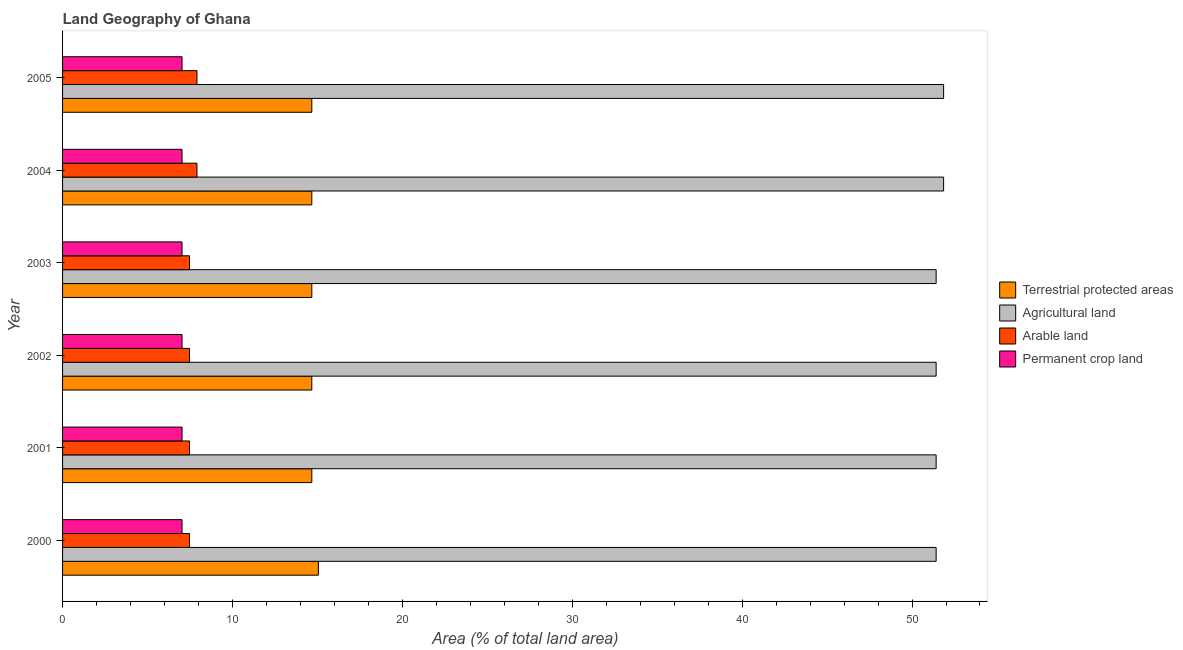How many groups of bars are there?
Offer a very short reply. 6. Are the number of bars per tick equal to the number of legend labels?
Give a very brief answer. Yes. How many bars are there on the 3rd tick from the top?
Provide a succinct answer. 4. How many bars are there on the 1st tick from the bottom?
Your answer should be compact. 4. In how many cases, is the number of bars for a given year not equal to the number of legend labels?
Ensure brevity in your answer.  0. What is the percentage of land under terrestrial protection in 2004?
Give a very brief answer. 14.67. Across all years, what is the maximum percentage of area under agricultural land?
Keep it short and to the point. 51.86. Across all years, what is the minimum percentage of area under permanent crop land?
Provide a short and direct response. 7.03. What is the total percentage of area under permanent crop land in the graph?
Your response must be concise. 42.19. What is the difference between the percentage of land under terrestrial protection in 2000 and the percentage of area under agricultural land in 2002?
Keep it short and to the point. -36.36. What is the average percentage of land under terrestrial protection per year?
Provide a short and direct response. 14.73. In the year 2004, what is the difference between the percentage of area under agricultural land and percentage of land under terrestrial protection?
Your answer should be very brief. 37.19. In how many years, is the percentage of area under arable land greater than 28 %?
Your response must be concise. 0. What is the ratio of the percentage of area under arable land in 2000 to that in 2005?
Your answer should be compact. 0.94. What is the difference between the highest and the lowest percentage of land under terrestrial protection?
Give a very brief answer. 0.39. What does the 2nd bar from the top in 2000 represents?
Offer a terse response. Arable land. What does the 1st bar from the bottom in 2000 represents?
Ensure brevity in your answer.  Terrestrial protected areas. Are all the bars in the graph horizontal?
Keep it short and to the point. Yes. How many years are there in the graph?
Keep it short and to the point. 6. Are the values on the major ticks of X-axis written in scientific E-notation?
Make the answer very short. No. Does the graph contain grids?
Offer a very short reply. No. What is the title of the graph?
Offer a terse response. Land Geography of Ghana. What is the label or title of the X-axis?
Your answer should be very brief. Area (% of total land area). What is the label or title of the Y-axis?
Offer a very short reply. Year. What is the Area (% of total land area) in Terrestrial protected areas in 2000?
Your answer should be very brief. 15.06. What is the Area (% of total land area) of Agricultural land in 2000?
Offer a terse response. 51.42. What is the Area (% of total land area) in Arable land in 2000?
Provide a short and direct response. 7.47. What is the Area (% of total land area) of Permanent crop land in 2000?
Keep it short and to the point. 7.03. What is the Area (% of total land area) of Terrestrial protected areas in 2001?
Offer a very short reply. 14.67. What is the Area (% of total land area) in Agricultural land in 2001?
Your response must be concise. 51.42. What is the Area (% of total land area) in Arable land in 2001?
Offer a very short reply. 7.47. What is the Area (% of total land area) of Permanent crop land in 2001?
Offer a terse response. 7.03. What is the Area (% of total land area) in Terrestrial protected areas in 2002?
Provide a short and direct response. 14.67. What is the Area (% of total land area) of Agricultural land in 2002?
Your answer should be compact. 51.42. What is the Area (% of total land area) in Arable land in 2002?
Give a very brief answer. 7.47. What is the Area (% of total land area) of Permanent crop land in 2002?
Give a very brief answer. 7.03. What is the Area (% of total land area) in Terrestrial protected areas in 2003?
Your answer should be very brief. 14.67. What is the Area (% of total land area) of Agricultural land in 2003?
Provide a succinct answer. 51.42. What is the Area (% of total land area) of Arable land in 2003?
Offer a terse response. 7.47. What is the Area (% of total land area) in Permanent crop land in 2003?
Keep it short and to the point. 7.03. What is the Area (% of total land area) of Terrestrial protected areas in 2004?
Make the answer very short. 14.67. What is the Area (% of total land area) of Agricultural land in 2004?
Offer a terse response. 51.86. What is the Area (% of total land area) in Arable land in 2004?
Keep it short and to the point. 7.91. What is the Area (% of total land area) in Permanent crop land in 2004?
Make the answer very short. 7.03. What is the Area (% of total land area) of Terrestrial protected areas in 2005?
Provide a succinct answer. 14.67. What is the Area (% of total land area) of Agricultural land in 2005?
Offer a terse response. 51.86. What is the Area (% of total land area) of Arable land in 2005?
Provide a succinct answer. 7.91. What is the Area (% of total land area) of Permanent crop land in 2005?
Give a very brief answer. 7.03. Across all years, what is the maximum Area (% of total land area) of Terrestrial protected areas?
Make the answer very short. 15.06. Across all years, what is the maximum Area (% of total land area) of Agricultural land?
Provide a short and direct response. 51.86. Across all years, what is the maximum Area (% of total land area) in Arable land?
Provide a short and direct response. 7.91. Across all years, what is the maximum Area (% of total land area) of Permanent crop land?
Your answer should be compact. 7.03. Across all years, what is the minimum Area (% of total land area) of Terrestrial protected areas?
Your response must be concise. 14.67. Across all years, what is the minimum Area (% of total land area) in Agricultural land?
Your answer should be compact. 51.42. Across all years, what is the minimum Area (% of total land area) of Arable land?
Make the answer very short. 7.47. Across all years, what is the minimum Area (% of total land area) in Permanent crop land?
Provide a short and direct response. 7.03. What is the total Area (% of total land area) in Terrestrial protected areas in the graph?
Provide a short and direct response. 88.41. What is the total Area (% of total land area) of Agricultural land in the graph?
Your answer should be very brief. 309.4. What is the total Area (% of total land area) in Arable land in the graph?
Your answer should be very brief. 45.71. What is the total Area (% of total land area) in Permanent crop land in the graph?
Make the answer very short. 42.19. What is the difference between the Area (% of total land area) in Terrestrial protected areas in 2000 and that in 2001?
Ensure brevity in your answer.  0.39. What is the difference between the Area (% of total land area) of Agricultural land in 2000 and that in 2001?
Provide a short and direct response. 0. What is the difference between the Area (% of total land area) of Arable land in 2000 and that in 2001?
Keep it short and to the point. 0. What is the difference between the Area (% of total land area) in Terrestrial protected areas in 2000 and that in 2002?
Your response must be concise. 0.39. What is the difference between the Area (% of total land area) of Agricultural land in 2000 and that in 2002?
Your answer should be compact. 0. What is the difference between the Area (% of total land area) in Permanent crop land in 2000 and that in 2002?
Your answer should be compact. 0. What is the difference between the Area (% of total land area) of Terrestrial protected areas in 2000 and that in 2003?
Give a very brief answer. 0.39. What is the difference between the Area (% of total land area) in Agricultural land in 2000 and that in 2003?
Offer a very short reply. 0. What is the difference between the Area (% of total land area) in Arable land in 2000 and that in 2003?
Give a very brief answer. 0. What is the difference between the Area (% of total land area) of Permanent crop land in 2000 and that in 2003?
Provide a succinct answer. 0. What is the difference between the Area (% of total land area) of Terrestrial protected areas in 2000 and that in 2004?
Provide a succinct answer. 0.39. What is the difference between the Area (% of total land area) in Agricultural land in 2000 and that in 2004?
Your answer should be compact. -0.44. What is the difference between the Area (% of total land area) of Arable land in 2000 and that in 2004?
Give a very brief answer. -0.44. What is the difference between the Area (% of total land area) of Permanent crop land in 2000 and that in 2004?
Make the answer very short. 0. What is the difference between the Area (% of total land area) of Terrestrial protected areas in 2000 and that in 2005?
Make the answer very short. 0.39. What is the difference between the Area (% of total land area) in Agricultural land in 2000 and that in 2005?
Your answer should be compact. -0.44. What is the difference between the Area (% of total land area) of Arable land in 2000 and that in 2005?
Your answer should be very brief. -0.44. What is the difference between the Area (% of total land area) of Permanent crop land in 2000 and that in 2005?
Provide a short and direct response. 0. What is the difference between the Area (% of total land area) of Terrestrial protected areas in 2001 and that in 2002?
Ensure brevity in your answer.  0. What is the difference between the Area (% of total land area) in Agricultural land in 2001 and that in 2002?
Keep it short and to the point. 0. What is the difference between the Area (% of total land area) in Arable land in 2001 and that in 2002?
Offer a very short reply. 0. What is the difference between the Area (% of total land area) of Permanent crop land in 2001 and that in 2002?
Your answer should be compact. 0. What is the difference between the Area (% of total land area) in Arable land in 2001 and that in 2003?
Your response must be concise. 0. What is the difference between the Area (% of total land area) in Terrestrial protected areas in 2001 and that in 2004?
Provide a succinct answer. 0. What is the difference between the Area (% of total land area) of Agricultural land in 2001 and that in 2004?
Provide a short and direct response. -0.44. What is the difference between the Area (% of total land area) in Arable land in 2001 and that in 2004?
Your answer should be very brief. -0.44. What is the difference between the Area (% of total land area) of Agricultural land in 2001 and that in 2005?
Offer a very short reply. -0.44. What is the difference between the Area (% of total land area) in Arable land in 2001 and that in 2005?
Your answer should be compact. -0.44. What is the difference between the Area (% of total land area) of Terrestrial protected areas in 2002 and that in 2003?
Provide a succinct answer. 0. What is the difference between the Area (% of total land area) in Arable land in 2002 and that in 2003?
Offer a very short reply. 0. What is the difference between the Area (% of total land area) in Permanent crop land in 2002 and that in 2003?
Offer a terse response. 0. What is the difference between the Area (% of total land area) of Agricultural land in 2002 and that in 2004?
Keep it short and to the point. -0.44. What is the difference between the Area (% of total land area) in Arable land in 2002 and that in 2004?
Ensure brevity in your answer.  -0.44. What is the difference between the Area (% of total land area) of Agricultural land in 2002 and that in 2005?
Ensure brevity in your answer.  -0.44. What is the difference between the Area (% of total land area) in Arable land in 2002 and that in 2005?
Make the answer very short. -0.44. What is the difference between the Area (% of total land area) of Agricultural land in 2003 and that in 2004?
Keep it short and to the point. -0.44. What is the difference between the Area (% of total land area) in Arable land in 2003 and that in 2004?
Your answer should be very brief. -0.44. What is the difference between the Area (% of total land area) in Permanent crop land in 2003 and that in 2004?
Keep it short and to the point. 0. What is the difference between the Area (% of total land area) in Terrestrial protected areas in 2003 and that in 2005?
Give a very brief answer. 0. What is the difference between the Area (% of total land area) in Agricultural land in 2003 and that in 2005?
Your answer should be compact. -0.44. What is the difference between the Area (% of total land area) of Arable land in 2003 and that in 2005?
Your answer should be compact. -0.44. What is the difference between the Area (% of total land area) of Arable land in 2004 and that in 2005?
Provide a succinct answer. 0. What is the difference between the Area (% of total land area) in Permanent crop land in 2004 and that in 2005?
Ensure brevity in your answer.  0. What is the difference between the Area (% of total land area) of Terrestrial protected areas in 2000 and the Area (% of total land area) of Agricultural land in 2001?
Provide a short and direct response. -36.36. What is the difference between the Area (% of total land area) of Terrestrial protected areas in 2000 and the Area (% of total land area) of Arable land in 2001?
Ensure brevity in your answer.  7.59. What is the difference between the Area (% of total land area) in Terrestrial protected areas in 2000 and the Area (% of total land area) in Permanent crop land in 2001?
Provide a succinct answer. 8.03. What is the difference between the Area (% of total land area) in Agricultural land in 2000 and the Area (% of total land area) in Arable land in 2001?
Keep it short and to the point. 43.95. What is the difference between the Area (% of total land area) in Agricultural land in 2000 and the Area (% of total land area) in Permanent crop land in 2001?
Offer a terse response. 44.39. What is the difference between the Area (% of total land area) of Arable land in 2000 and the Area (% of total land area) of Permanent crop land in 2001?
Give a very brief answer. 0.44. What is the difference between the Area (% of total land area) of Terrestrial protected areas in 2000 and the Area (% of total land area) of Agricultural land in 2002?
Keep it short and to the point. -36.36. What is the difference between the Area (% of total land area) in Terrestrial protected areas in 2000 and the Area (% of total land area) in Arable land in 2002?
Provide a short and direct response. 7.59. What is the difference between the Area (% of total land area) in Terrestrial protected areas in 2000 and the Area (% of total land area) in Permanent crop land in 2002?
Your answer should be very brief. 8.03. What is the difference between the Area (% of total land area) of Agricultural land in 2000 and the Area (% of total land area) of Arable land in 2002?
Your answer should be very brief. 43.95. What is the difference between the Area (% of total land area) of Agricultural land in 2000 and the Area (% of total land area) of Permanent crop land in 2002?
Your answer should be very brief. 44.39. What is the difference between the Area (% of total land area) of Arable land in 2000 and the Area (% of total land area) of Permanent crop land in 2002?
Your response must be concise. 0.44. What is the difference between the Area (% of total land area) in Terrestrial protected areas in 2000 and the Area (% of total land area) in Agricultural land in 2003?
Provide a short and direct response. -36.36. What is the difference between the Area (% of total land area) in Terrestrial protected areas in 2000 and the Area (% of total land area) in Arable land in 2003?
Keep it short and to the point. 7.59. What is the difference between the Area (% of total land area) in Terrestrial protected areas in 2000 and the Area (% of total land area) in Permanent crop land in 2003?
Your answer should be compact. 8.03. What is the difference between the Area (% of total land area) in Agricultural land in 2000 and the Area (% of total land area) in Arable land in 2003?
Your answer should be very brief. 43.95. What is the difference between the Area (% of total land area) in Agricultural land in 2000 and the Area (% of total land area) in Permanent crop land in 2003?
Your response must be concise. 44.39. What is the difference between the Area (% of total land area) of Arable land in 2000 and the Area (% of total land area) of Permanent crop land in 2003?
Your answer should be very brief. 0.44. What is the difference between the Area (% of total land area) of Terrestrial protected areas in 2000 and the Area (% of total land area) of Agricultural land in 2004?
Offer a terse response. -36.8. What is the difference between the Area (% of total land area) of Terrestrial protected areas in 2000 and the Area (% of total land area) of Arable land in 2004?
Offer a very short reply. 7.15. What is the difference between the Area (% of total land area) in Terrestrial protected areas in 2000 and the Area (% of total land area) in Permanent crop land in 2004?
Offer a very short reply. 8.03. What is the difference between the Area (% of total land area) of Agricultural land in 2000 and the Area (% of total land area) of Arable land in 2004?
Ensure brevity in your answer.  43.51. What is the difference between the Area (% of total land area) of Agricultural land in 2000 and the Area (% of total land area) of Permanent crop land in 2004?
Your answer should be compact. 44.39. What is the difference between the Area (% of total land area) of Arable land in 2000 and the Area (% of total land area) of Permanent crop land in 2004?
Your response must be concise. 0.44. What is the difference between the Area (% of total land area) in Terrestrial protected areas in 2000 and the Area (% of total land area) in Agricultural land in 2005?
Ensure brevity in your answer.  -36.8. What is the difference between the Area (% of total land area) of Terrestrial protected areas in 2000 and the Area (% of total land area) of Arable land in 2005?
Ensure brevity in your answer.  7.15. What is the difference between the Area (% of total land area) of Terrestrial protected areas in 2000 and the Area (% of total land area) of Permanent crop land in 2005?
Your answer should be very brief. 8.03. What is the difference between the Area (% of total land area) of Agricultural land in 2000 and the Area (% of total land area) of Arable land in 2005?
Keep it short and to the point. 43.51. What is the difference between the Area (% of total land area) in Agricultural land in 2000 and the Area (% of total land area) in Permanent crop land in 2005?
Your answer should be very brief. 44.39. What is the difference between the Area (% of total land area) of Arable land in 2000 and the Area (% of total land area) of Permanent crop land in 2005?
Keep it short and to the point. 0.44. What is the difference between the Area (% of total land area) in Terrestrial protected areas in 2001 and the Area (% of total land area) in Agricultural land in 2002?
Make the answer very short. -36.75. What is the difference between the Area (% of total land area) of Terrestrial protected areas in 2001 and the Area (% of total land area) of Arable land in 2002?
Make the answer very short. 7.2. What is the difference between the Area (% of total land area) in Terrestrial protected areas in 2001 and the Area (% of total land area) in Permanent crop land in 2002?
Your response must be concise. 7.64. What is the difference between the Area (% of total land area) of Agricultural land in 2001 and the Area (% of total land area) of Arable land in 2002?
Make the answer very short. 43.95. What is the difference between the Area (% of total land area) of Agricultural land in 2001 and the Area (% of total land area) of Permanent crop land in 2002?
Provide a short and direct response. 44.39. What is the difference between the Area (% of total land area) of Arable land in 2001 and the Area (% of total land area) of Permanent crop land in 2002?
Your response must be concise. 0.44. What is the difference between the Area (% of total land area) of Terrestrial protected areas in 2001 and the Area (% of total land area) of Agricultural land in 2003?
Your answer should be compact. -36.75. What is the difference between the Area (% of total land area) in Terrestrial protected areas in 2001 and the Area (% of total land area) in Arable land in 2003?
Your answer should be very brief. 7.2. What is the difference between the Area (% of total land area) of Terrestrial protected areas in 2001 and the Area (% of total land area) of Permanent crop land in 2003?
Offer a very short reply. 7.64. What is the difference between the Area (% of total land area) in Agricultural land in 2001 and the Area (% of total land area) in Arable land in 2003?
Give a very brief answer. 43.95. What is the difference between the Area (% of total land area) of Agricultural land in 2001 and the Area (% of total land area) of Permanent crop land in 2003?
Your answer should be very brief. 44.39. What is the difference between the Area (% of total land area) of Arable land in 2001 and the Area (% of total land area) of Permanent crop land in 2003?
Give a very brief answer. 0.44. What is the difference between the Area (% of total land area) in Terrestrial protected areas in 2001 and the Area (% of total land area) in Agricultural land in 2004?
Your answer should be compact. -37.19. What is the difference between the Area (% of total land area) in Terrestrial protected areas in 2001 and the Area (% of total land area) in Arable land in 2004?
Your answer should be compact. 6.76. What is the difference between the Area (% of total land area) of Terrestrial protected areas in 2001 and the Area (% of total land area) of Permanent crop land in 2004?
Provide a short and direct response. 7.64. What is the difference between the Area (% of total land area) of Agricultural land in 2001 and the Area (% of total land area) of Arable land in 2004?
Your response must be concise. 43.51. What is the difference between the Area (% of total land area) of Agricultural land in 2001 and the Area (% of total land area) of Permanent crop land in 2004?
Ensure brevity in your answer.  44.39. What is the difference between the Area (% of total land area) of Arable land in 2001 and the Area (% of total land area) of Permanent crop land in 2004?
Ensure brevity in your answer.  0.44. What is the difference between the Area (% of total land area) of Terrestrial protected areas in 2001 and the Area (% of total land area) of Agricultural land in 2005?
Offer a terse response. -37.19. What is the difference between the Area (% of total land area) in Terrestrial protected areas in 2001 and the Area (% of total land area) in Arable land in 2005?
Make the answer very short. 6.76. What is the difference between the Area (% of total land area) in Terrestrial protected areas in 2001 and the Area (% of total land area) in Permanent crop land in 2005?
Your response must be concise. 7.64. What is the difference between the Area (% of total land area) in Agricultural land in 2001 and the Area (% of total land area) in Arable land in 2005?
Your answer should be compact. 43.51. What is the difference between the Area (% of total land area) of Agricultural land in 2001 and the Area (% of total land area) of Permanent crop land in 2005?
Your answer should be compact. 44.39. What is the difference between the Area (% of total land area) in Arable land in 2001 and the Area (% of total land area) in Permanent crop land in 2005?
Your response must be concise. 0.44. What is the difference between the Area (% of total land area) of Terrestrial protected areas in 2002 and the Area (% of total land area) of Agricultural land in 2003?
Ensure brevity in your answer.  -36.75. What is the difference between the Area (% of total land area) of Terrestrial protected areas in 2002 and the Area (% of total land area) of Arable land in 2003?
Ensure brevity in your answer.  7.2. What is the difference between the Area (% of total land area) of Terrestrial protected areas in 2002 and the Area (% of total land area) of Permanent crop land in 2003?
Provide a succinct answer. 7.64. What is the difference between the Area (% of total land area) of Agricultural land in 2002 and the Area (% of total land area) of Arable land in 2003?
Provide a short and direct response. 43.95. What is the difference between the Area (% of total land area) of Agricultural land in 2002 and the Area (% of total land area) of Permanent crop land in 2003?
Your answer should be very brief. 44.39. What is the difference between the Area (% of total land area) in Arable land in 2002 and the Area (% of total land area) in Permanent crop land in 2003?
Offer a terse response. 0.44. What is the difference between the Area (% of total land area) in Terrestrial protected areas in 2002 and the Area (% of total land area) in Agricultural land in 2004?
Provide a succinct answer. -37.19. What is the difference between the Area (% of total land area) in Terrestrial protected areas in 2002 and the Area (% of total land area) in Arable land in 2004?
Provide a succinct answer. 6.76. What is the difference between the Area (% of total land area) of Terrestrial protected areas in 2002 and the Area (% of total land area) of Permanent crop land in 2004?
Make the answer very short. 7.64. What is the difference between the Area (% of total land area) in Agricultural land in 2002 and the Area (% of total land area) in Arable land in 2004?
Your response must be concise. 43.51. What is the difference between the Area (% of total land area) of Agricultural land in 2002 and the Area (% of total land area) of Permanent crop land in 2004?
Offer a terse response. 44.39. What is the difference between the Area (% of total land area) of Arable land in 2002 and the Area (% of total land area) of Permanent crop land in 2004?
Give a very brief answer. 0.44. What is the difference between the Area (% of total land area) of Terrestrial protected areas in 2002 and the Area (% of total land area) of Agricultural land in 2005?
Keep it short and to the point. -37.19. What is the difference between the Area (% of total land area) of Terrestrial protected areas in 2002 and the Area (% of total land area) of Arable land in 2005?
Keep it short and to the point. 6.76. What is the difference between the Area (% of total land area) of Terrestrial protected areas in 2002 and the Area (% of total land area) of Permanent crop land in 2005?
Offer a terse response. 7.64. What is the difference between the Area (% of total land area) in Agricultural land in 2002 and the Area (% of total land area) in Arable land in 2005?
Provide a succinct answer. 43.51. What is the difference between the Area (% of total land area) of Agricultural land in 2002 and the Area (% of total land area) of Permanent crop land in 2005?
Provide a succinct answer. 44.39. What is the difference between the Area (% of total land area) in Arable land in 2002 and the Area (% of total land area) in Permanent crop land in 2005?
Ensure brevity in your answer.  0.44. What is the difference between the Area (% of total land area) in Terrestrial protected areas in 2003 and the Area (% of total land area) in Agricultural land in 2004?
Provide a succinct answer. -37.19. What is the difference between the Area (% of total land area) in Terrestrial protected areas in 2003 and the Area (% of total land area) in Arable land in 2004?
Your answer should be very brief. 6.76. What is the difference between the Area (% of total land area) in Terrestrial protected areas in 2003 and the Area (% of total land area) in Permanent crop land in 2004?
Your response must be concise. 7.64. What is the difference between the Area (% of total land area) of Agricultural land in 2003 and the Area (% of total land area) of Arable land in 2004?
Provide a succinct answer. 43.51. What is the difference between the Area (% of total land area) in Agricultural land in 2003 and the Area (% of total land area) in Permanent crop land in 2004?
Provide a short and direct response. 44.39. What is the difference between the Area (% of total land area) in Arable land in 2003 and the Area (% of total land area) in Permanent crop land in 2004?
Offer a very short reply. 0.44. What is the difference between the Area (% of total land area) of Terrestrial protected areas in 2003 and the Area (% of total land area) of Agricultural land in 2005?
Your answer should be very brief. -37.19. What is the difference between the Area (% of total land area) in Terrestrial protected areas in 2003 and the Area (% of total land area) in Arable land in 2005?
Your answer should be very brief. 6.76. What is the difference between the Area (% of total land area) in Terrestrial protected areas in 2003 and the Area (% of total land area) in Permanent crop land in 2005?
Provide a short and direct response. 7.64. What is the difference between the Area (% of total land area) of Agricultural land in 2003 and the Area (% of total land area) of Arable land in 2005?
Your response must be concise. 43.51. What is the difference between the Area (% of total land area) of Agricultural land in 2003 and the Area (% of total land area) of Permanent crop land in 2005?
Provide a succinct answer. 44.39. What is the difference between the Area (% of total land area) in Arable land in 2003 and the Area (% of total land area) in Permanent crop land in 2005?
Offer a terse response. 0.44. What is the difference between the Area (% of total land area) of Terrestrial protected areas in 2004 and the Area (% of total land area) of Agricultural land in 2005?
Make the answer very short. -37.19. What is the difference between the Area (% of total land area) of Terrestrial protected areas in 2004 and the Area (% of total land area) of Arable land in 2005?
Make the answer very short. 6.76. What is the difference between the Area (% of total land area) of Terrestrial protected areas in 2004 and the Area (% of total land area) of Permanent crop land in 2005?
Provide a succinct answer. 7.64. What is the difference between the Area (% of total land area) of Agricultural land in 2004 and the Area (% of total land area) of Arable land in 2005?
Offer a very short reply. 43.95. What is the difference between the Area (% of total land area) of Agricultural land in 2004 and the Area (% of total land area) of Permanent crop land in 2005?
Provide a succinct answer. 44.83. What is the difference between the Area (% of total land area) in Arable land in 2004 and the Area (% of total land area) in Permanent crop land in 2005?
Provide a short and direct response. 0.88. What is the average Area (% of total land area) in Terrestrial protected areas per year?
Ensure brevity in your answer.  14.74. What is the average Area (% of total land area) in Agricultural land per year?
Offer a very short reply. 51.57. What is the average Area (% of total land area) in Arable land per year?
Offer a terse response. 7.62. What is the average Area (% of total land area) of Permanent crop land per year?
Provide a succinct answer. 7.03. In the year 2000, what is the difference between the Area (% of total land area) in Terrestrial protected areas and Area (% of total land area) in Agricultural land?
Give a very brief answer. -36.36. In the year 2000, what is the difference between the Area (% of total land area) in Terrestrial protected areas and Area (% of total land area) in Arable land?
Ensure brevity in your answer.  7.59. In the year 2000, what is the difference between the Area (% of total land area) in Terrestrial protected areas and Area (% of total land area) in Permanent crop land?
Ensure brevity in your answer.  8.03. In the year 2000, what is the difference between the Area (% of total land area) in Agricultural land and Area (% of total land area) in Arable land?
Make the answer very short. 43.95. In the year 2000, what is the difference between the Area (% of total land area) of Agricultural land and Area (% of total land area) of Permanent crop land?
Offer a terse response. 44.39. In the year 2000, what is the difference between the Area (% of total land area) of Arable land and Area (% of total land area) of Permanent crop land?
Provide a short and direct response. 0.44. In the year 2001, what is the difference between the Area (% of total land area) in Terrestrial protected areas and Area (% of total land area) in Agricultural land?
Offer a terse response. -36.75. In the year 2001, what is the difference between the Area (% of total land area) of Terrestrial protected areas and Area (% of total land area) of Arable land?
Ensure brevity in your answer.  7.2. In the year 2001, what is the difference between the Area (% of total land area) of Terrestrial protected areas and Area (% of total land area) of Permanent crop land?
Your answer should be compact. 7.64. In the year 2001, what is the difference between the Area (% of total land area) in Agricultural land and Area (% of total land area) in Arable land?
Ensure brevity in your answer.  43.95. In the year 2001, what is the difference between the Area (% of total land area) of Agricultural land and Area (% of total land area) of Permanent crop land?
Ensure brevity in your answer.  44.39. In the year 2001, what is the difference between the Area (% of total land area) of Arable land and Area (% of total land area) of Permanent crop land?
Make the answer very short. 0.44. In the year 2002, what is the difference between the Area (% of total land area) in Terrestrial protected areas and Area (% of total land area) in Agricultural land?
Keep it short and to the point. -36.75. In the year 2002, what is the difference between the Area (% of total land area) of Terrestrial protected areas and Area (% of total land area) of Arable land?
Ensure brevity in your answer.  7.2. In the year 2002, what is the difference between the Area (% of total land area) of Terrestrial protected areas and Area (% of total land area) of Permanent crop land?
Keep it short and to the point. 7.64. In the year 2002, what is the difference between the Area (% of total land area) in Agricultural land and Area (% of total land area) in Arable land?
Give a very brief answer. 43.95. In the year 2002, what is the difference between the Area (% of total land area) in Agricultural land and Area (% of total land area) in Permanent crop land?
Your answer should be compact. 44.39. In the year 2002, what is the difference between the Area (% of total land area) in Arable land and Area (% of total land area) in Permanent crop land?
Provide a short and direct response. 0.44. In the year 2003, what is the difference between the Area (% of total land area) of Terrestrial protected areas and Area (% of total land area) of Agricultural land?
Your answer should be compact. -36.75. In the year 2003, what is the difference between the Area (% of total land area) in Terrestrial protected areas and Area (% of total land area) in Arable land?
Keep it short and to the point. 7.2. In the year 2003, what is the difference between the Area (% of total land area) in Terrestrial protected areas and Area (% of total land area) in Permanent crop land?
Ensure brevity in your answer.  7.64. In the year 2003, what is the difference between the Area (% of total land area) in Agricultural land and Area (% of total land area) in Arable land?
Offer a very short reply. 43.95. In the year 2003, what is the difference between the Area (% of total land area) of Agricultural land and Area (% of total land area) of Permanent crop land?
Ensure brevity in your answer.  44.39. In the year 2003, what is the difference between the Area (% of total land area) in Arable land and Area (% of total land area) in Permanent crop land?
Your answer should be compact. 0.44. In the year 2004, what is the difference between the Area (% of total land area) of Terrestrial protected areas and Area (% of total land area) of Agricultural land?
Keep it short and to the point. -37.19. In the year 2004, what is the difference between the Area (% of total land area) of Terrestrial protected areas and Area (% of total land area) of Arable land?
Offer a very short reply. 6.76. In the year 2004, what is the difference between the Area (% of total land area) of Terrestrial protected areas and Area (% of total land area) of Permanent crop land?
Give a very brief answer. 7.64. In the year 2004, what is the difference between the Area (% of total land area) of Agricultural land and Area (% of total land area) of Arable land?
Your answer should be compact. 43.95. In the year 2004, what is the difference between the Area (% of total land area) of Agricultural land and Area (% of total land area) of Permanent crop land?
Provide a succinct answer. 44.83. In the year 2004, what is the difference between the Area (% of total land area) in Arable land and Area (% of total land area) in Permanent crop land?
Make the answer very short. 0.88. In the year 2005, what is the difference between the Area (% of total land area) in Terrestrial protected areas and Area (% of total land area) in Agricultural land?
Ensure brevity in your answer.  -37.19. In the year 2005, what is the difference between the Area (% of total land area) in Terrestrial protected areas and Area (% of total land area) in Arable land?
Offer a very short reply. 6.76. In the year 2005, what is the difference between the Area (% of total land area) of Terrestrial protected areas and Area (% of total land area) of Permanent crop land?
Make the answer very short. 7.64. In the year 2005, what is the difference between the Area (% of total land area) of Agricultural land and Area (% of total land area) of Arable land?
Ensure brevity in your answer.  43.95. In the year 2005, what is the difference between the Area (% of total land area) in Agricultural land and Area (% of total land area) in Permanent crop land?
Give a very brief answer. 44.83. In the year 2005, what is the difference between the Area (% of total land area) of Arable land and Area (% of total land area) of Permanent crop land?
Your answer should be compact. 0.88. What is the ratio of the Area (% of total land area) in Terrestrial protected areas in 2000 to that in 2001?
Your response must be concise. 1.03. What is the ratio of the Area (% of total land area) in Arable land in 2000 to that in 2001?
Offer a very short reply. 1. What is the ratio of the Area (% of total land area) of Permanent crop land in 2000 to that in 2001?
Offer a very short reply. 1. What is the ratio of the Area (% of total land area) in Terrestrial protected areas in 2000 to that in 2002?
Give a very brief answer. 1.03. What is the ratio of the Area (% of total land area) of Agricultural land in 2000 to that in 2002?
Give a very brief answer. 1. What is the ratio of the Area (% of total land area) of Permanent crop land in 2000 to that in 2002?
Your answer should be very brief. 1. What is the ratio of the Area (% of total land area) of Terrestrial protected areas in 2000 to that in 2003?
Your answer should be very brief. 1.03. What is the ratio of the Area (% of total land area) in Agricultural land in 2000 to that in 2003?
Your response must be concise. 1. What is the ratio of the Area (% of total land area) of Terrestrial protected areas in 2000 to that in 2004?
Give a very brief answer. 1.03. What is the ratio of the Area (% of total land area) of Arable land in 2000 to that in 2004?
Offer a very short reply. 0.94. What is the ratio of the Area (% of total land area) of Permanent crop land in 2000 to that in 2004?
Ensure brevity in your answer.  1. What is the ratio of the Area (% of total land area) in Terrestrial protected areas in 2000 to that in 2005?
Provide a short and direct response. 1.03. What is the ratio of the Area (% of total land area) in Arable land in 2000 to that in 2005?
Make the answer very short. 0.94. What is the ratio of the Area (% of total land area) of Terrestrial protected areas in 2001 to that in 2002?
Your response must be concise. 1. What is the ratio of the Area (% of total land area) in Agricultural land in 2001 to that in 2002?
Give a very brief answer. 1. What is the ratio of the Area (% of total land area) of Arable land in 2001 to that in 2002?
Ensure brevity in your answer.  1. What is the ratio of the Area (% of total land area) of Agricultural land in 2001 to that in 2003?
Your answer should be compact. 1. What is the ratio of the Area (% of total land area) of Arable land in 2001 to that in 2003?
Your response must be concise. 1. What is the ratio of the Area (% of total land area) of Permanent crop land in 2001 to that in 2003?
Your answer should be compact. 1. What is the ratio of the Area (% of total land area) of Terrestrial protected areas in 2001 to that in 2004?
Your answer should be compact. 1. What is the ratio of the Area (% of total land area) of Agricultural land in 2001 to that in 2004?
Keep it short and to the point. 0.99. What is the ratio of the Area (% of total land area) of Arable land in 2001 to that in 2004?
Offer a terse response. 0.94. What is the ratio of the Area (% of total land area) in Permanent crop land in 2001 to that in 2004?
Provide a short and direct response. 1. What is the ratio of the Area (% of total land area) in Arable land in 2001 to that in 2005?
Ensure brevity in your answer.  0.94. What is the ratio of the Area (% of total land area) in Terrestrial protected areas in 2002 to that in 2003?
Your answer should be very brief. 1. What is the ratio of the Area (% of total land area) in Agricultural land in 2002 to that in 2003?
Offer a terse response. 1. What is the ratio of the Area (% of total land area) of Permanent crop land in 2002 to that in 2003?
Your answer should be very brief. 1. What is the ratio of the Area (% of total land area) in Terrestrial protected areas in 2002 to that in 2004?
Your answer should be compact. 1. What is the ratio of the Area (% of total land area) of Agricultural land in 2002 to that in 2004?
Your response must be concise. 0.99. What is the ratio of the Area (% of total land area) of Arable land in 2002 to that in 2004?
Your answer should be very brief. 0.94. What is the ratio of the Area (% of total land area) in Permanent crop land in 2002 to that in 2004?
Make the answer very short. 1. What is the ratio of the Area (% of total land area) of Agricultural land in 2002 to that in 2005?
Your response must be concise. 0.99. What is the ratio of the Area (% of total land area) of Arable land in 2002 to that in 2005?
Give a very brief answer. 0.94. What is the ratio of the Area (% of total land area) in Permanent crop land in 2002 to that in 2005?
Offer a terse response. 1. What is the ratio of the Area (% of total land area) in Agricultural land in 2003 to that in 2004?
Your answer should be very brief. 0.99. What is the ratio of the Area (% of total land area) of Terrestrial protected areas in 2004 to that in 2005?
Provide a short and direct response. 1. What is the ratio of the Area (% of total land area) of Agricultural land in 2004 to that in 2005?
Give a very brief answer. 1. What is the difference between the highest and the second highest Area (% of total land area) of Terrestrial protected areas?
Offer a terse response. 0.39. What is the difference between the highest and the second highest Area (% of total land area) in Permanent crop land?
Keep it short and to the point. 0. What is the difference between the highest and the lowest Area (% of total land area) of Terrestrial protected areas?
Your response must be concise. 0.39. What is the difference between the highest and the lowest Area (% of total land area) in Agricultural land?
Ensure brevity in your answer.  0.44. What is the difference between the highest and the lowest Area (% of total land area) of Arable land?
Your answer should be compact. 0.44. 